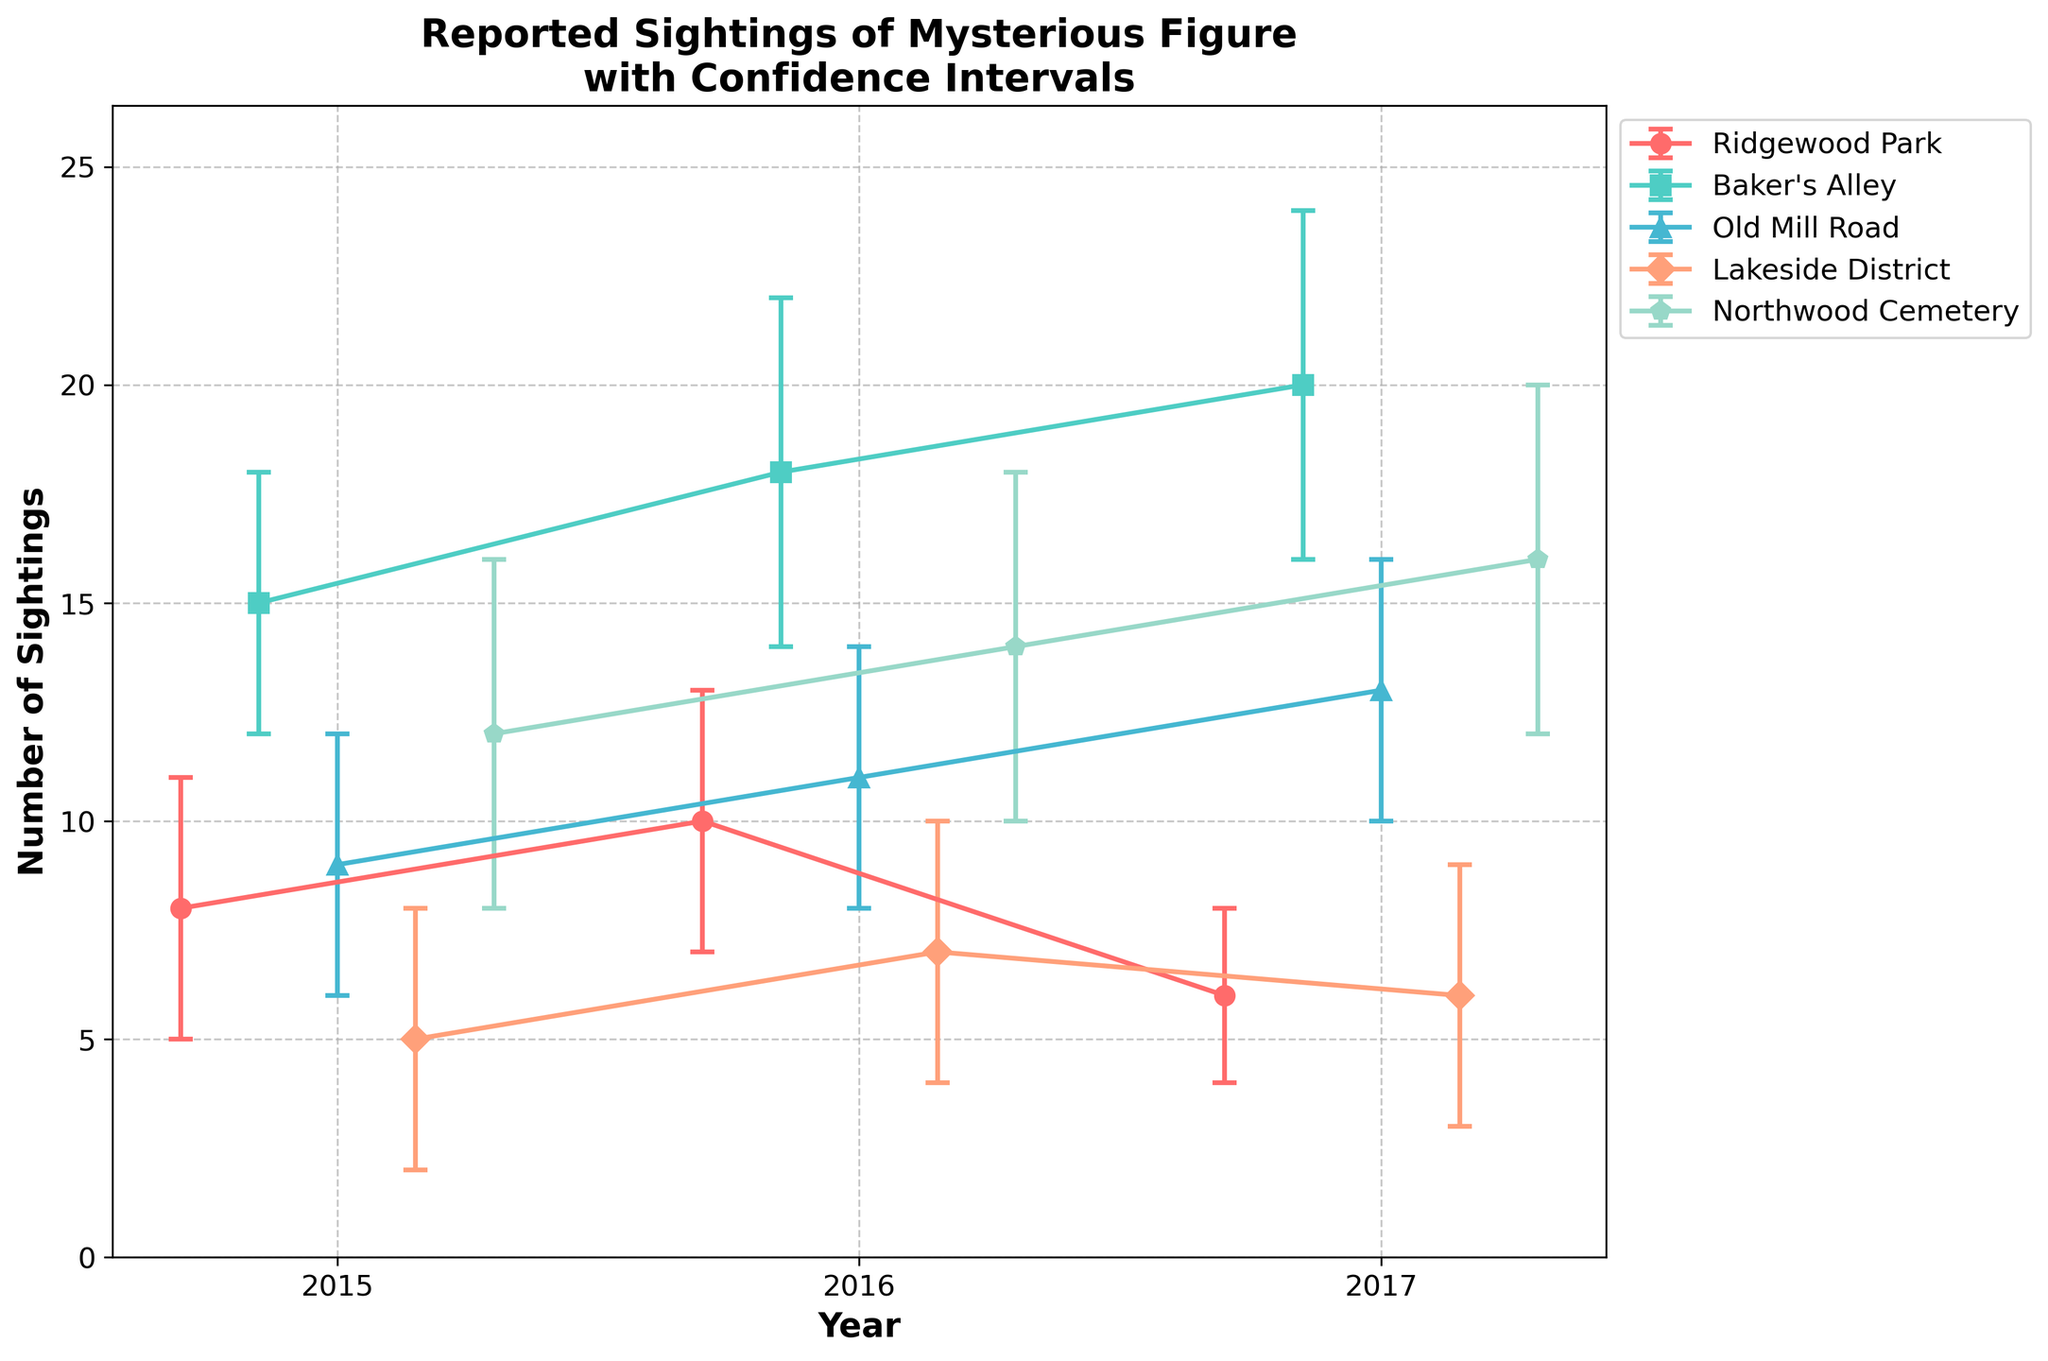Which location had the highest number of sightings in 2015? Examine the sightings bars for each location in 2015. Compare their heights to determine which one is the tallest.
Answer: Baker's Alley Which year had the lowest reported sightings in Ridgewood Park? Focus on the data points for Ridgewood Park. Comparing the sightings for 2015, 2016, and 2017, identify the year with the lowest value.
Answer: 2017 What's the difference in sightings between 2017 and 2015 in Old Mill Road? Look at the sighting values for Old Mill Road in 2017 and 2015. Subtract the 2015 value from the 2017 value.
Answer: 4 How do the confidence intervals compare for sightings in 2016 at Ridgewood Park and Lakeside District? Identify the upper and lower confidence intervals for both locations in 2016. Compare the ranges. Ridgewood Park: (7, 13) and Lakeside District: (4, 10).
Answer: They are equal Did any location observe a consistent increase in sightings from 2015 to 2017? Analyze the trendlines for each location from 2015 to 2017. Baker's Alley shows a consistent increase with values 15, 18, and 20.
Answer: Baker's Alley How many total sightings were reported across all locations in 2016? Sum the number of sightings for each location in 2016: (10+18+11+7+14). Calculate: 10 + 18 + 11 + 7 + 14 = 60.
Answer: 60 Which location had the narrowest confidence interval range in 2017? Calculate the confidence interval range for each location in 2017. Ridgewood Park: 4-8, Baker’s Alley: 16-24, Old Mill Road: 10-16, Lakeside District: 3-9, Northwood Cemetery: 12-20. Compare the ranges to find the smallest.
Answer: Ridgewood Park In what year did Northwood Cemetery have the highest sightings? Examine the data points for Northwood Cemetery. Compare values for 2015, 2016, and 2017 to find the highest.
Answer: 2017 What's the average number of sightings in Baker's Alley over the three-year period? Add the sightings for all years in Baker's Alley and divide by 3. (15+18+20)/3 = 53/3.
Answer: Approximately 17.7 Which location had more sightings on average in 2017, Ridgewood Park or Lakeside District? Compare the sightings value in 2017 for Ridgewood Park and Lakeside District. Ridgewood Park: 6, Lakeside District: 6, they are equal.
Answer: Equal 